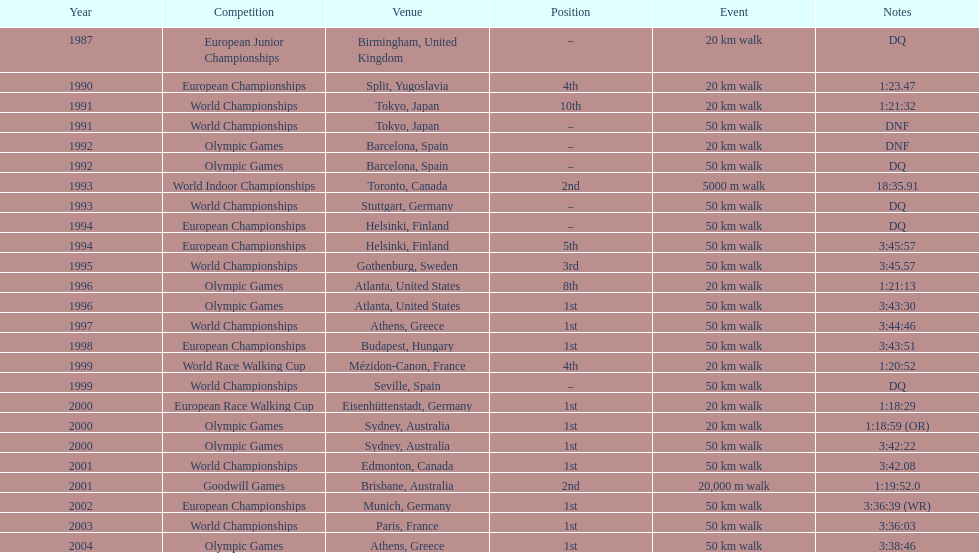What was the disparity in korzeniowski's performance during the 20 km walk at the 1996 olympic games compared to the 2000 olympic games? 2:14. 